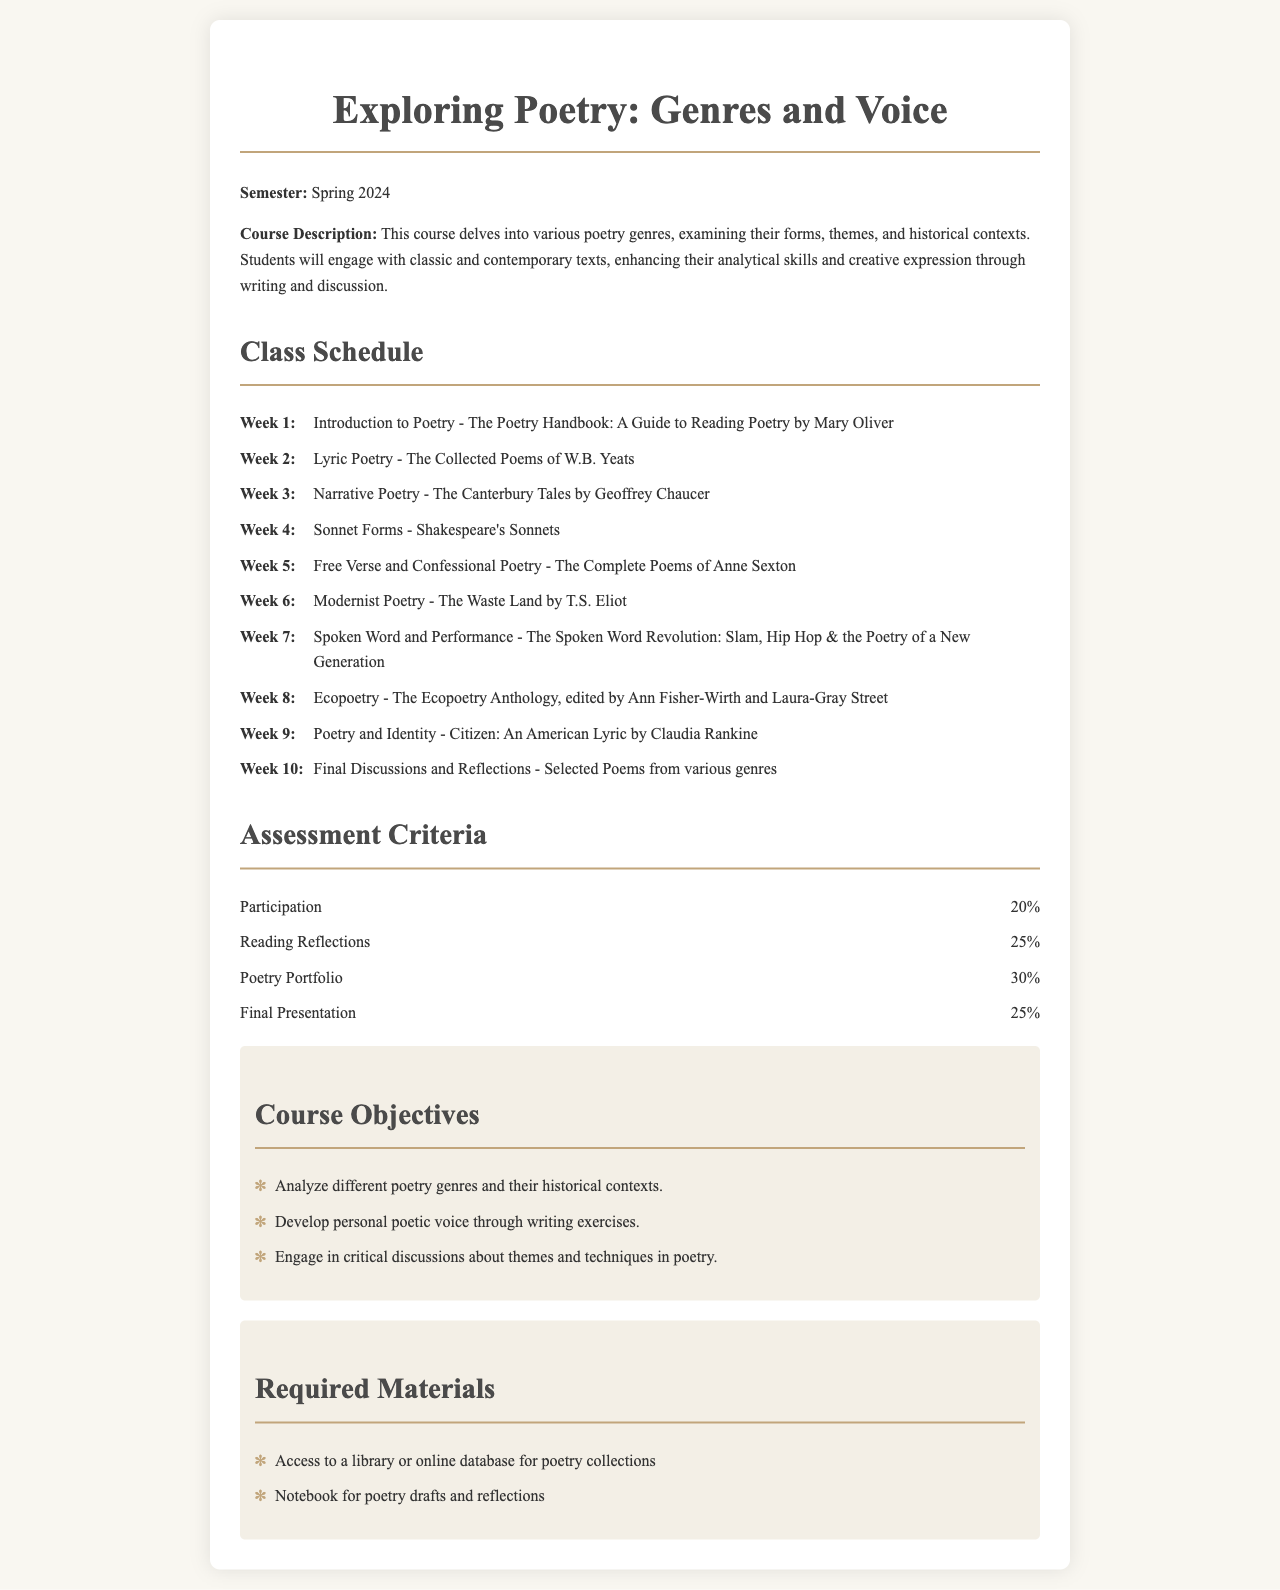What is the title of the course? The title of the course is indicated prominently at the top of the document.
Answer: Exploring Poetry: Genres and Voice What is the total percentage for the Poetry Portfolio assessment? The document specifies the percentage allocated to the Poetry Portfolio in the assessment criteria section.
Answer: 30% Which poem collection is studied in Week 2? The readings for each week are listed chronologically, and Week 2 specifies the collection clearly.
Answer: The Collected Poems of W.B. Yeats How many weeks are dedicated to poetry genres in the syllabus? The schedule lists readings for each week, and by counting them, we find the total.
Answer: 10 What is the required material related to reflections? The required materials include specific items needed for the course; one of them directly mentions reflections.
Answer: Notebook for poetry drafts and reflections Which poet's work is featured during Week 6? The document lists the readings by week, which includes specific examples of poets and their works.
Answer: T.S. Eliot What percentage of the grade is based on Participation? The breakdown of assessment criteria provides specific percentages for each category, including Participation.
Answer: 20% What genre of poetry is discussed in Week 8? The week’s theme is explicitly stated in the schedule alongside the associated reading.
Answer: Ecopoetry What is the primary objective regarding personal expression in this course? The course objectives section highlights specific goals, one of which pertains to personal poetic voice.
Answer: Develop personal poetic voice through writing exercises 